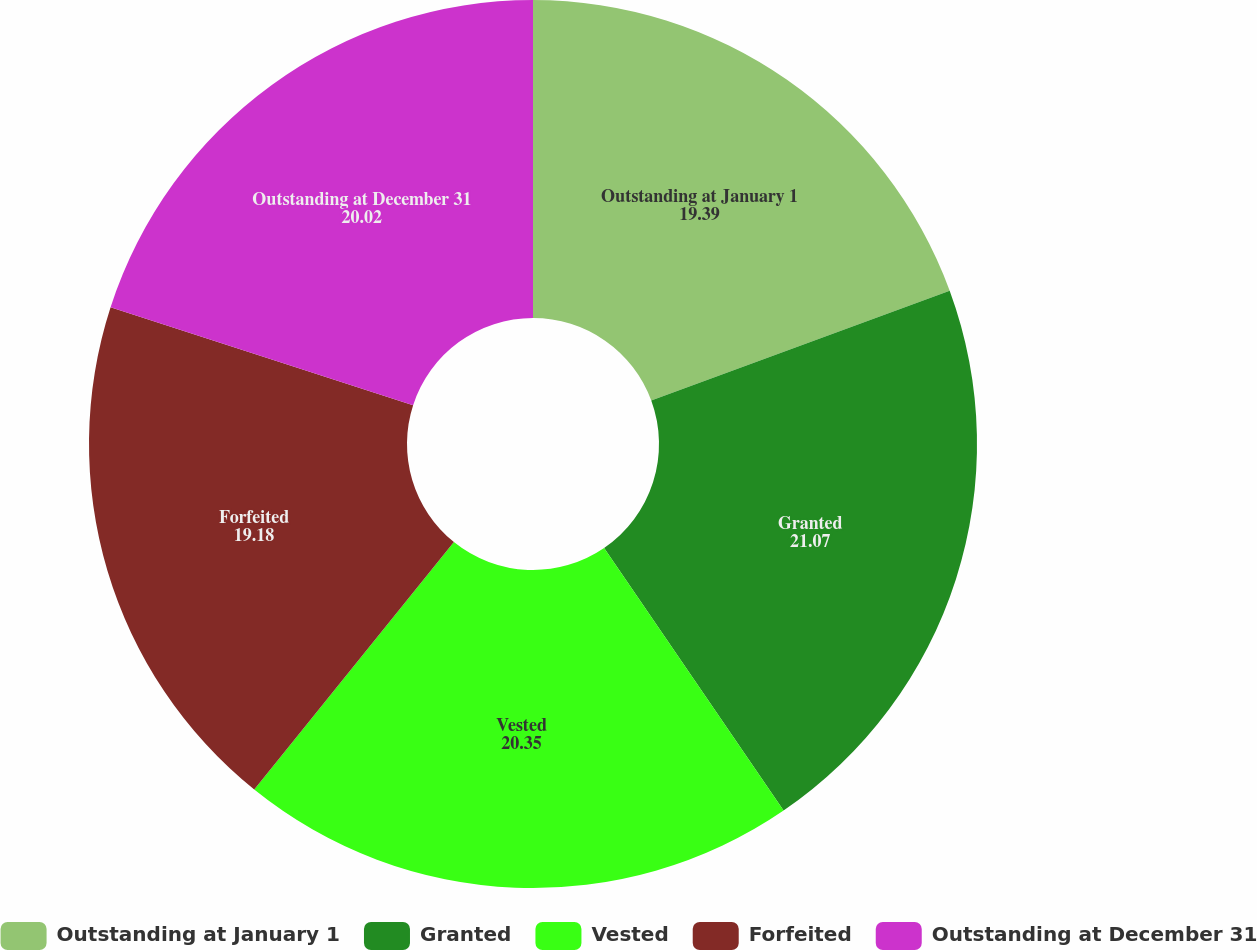<chart> <loc_0><loc_0><loc_500><loc_500><pie_chart><fcel>Outstanding at January 1<fcel>Granted<fcel>Vested<fcel>Forfeited<fcel>Outstanding at December 31<nl><fcel>19.39%<fcel>21.07%<fcel>20.35%<fcel>19.18%<fcel>20.02%<nl></chart> 